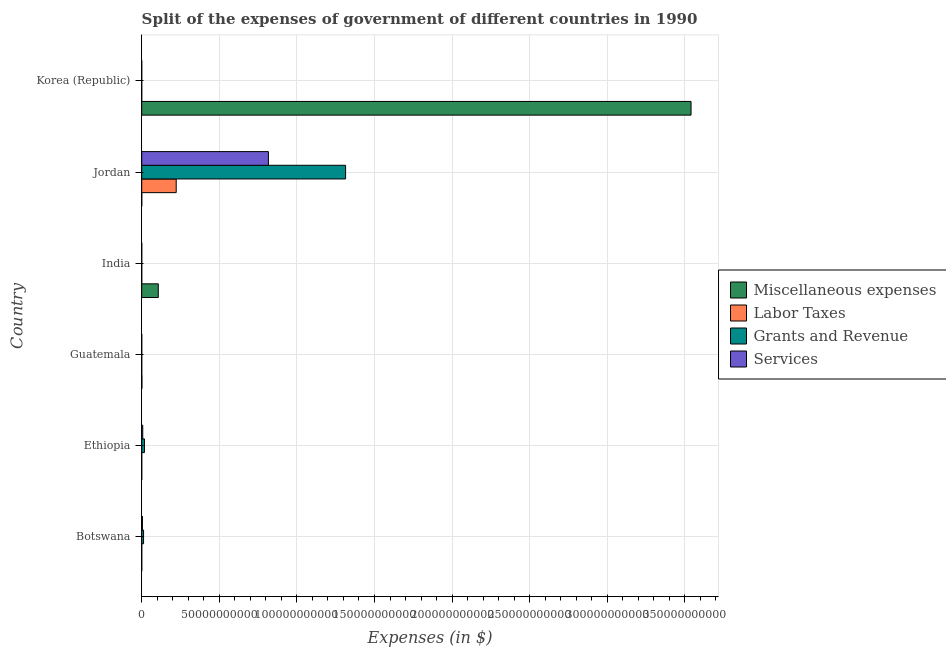How many groups of bars are there?
Give a very brief answer. 6. Are the number of bars per tick equal to the number of legend labels?
Provide a succinct answer. Yes. Are the number of bars on each tick of the Y-axis equal?
Offer a terse response. Yes. How many bars are there on the 1st tick from the top?
Your response must be concise. 4. How many bars are there on the 3rd tick from the bottom?
Offer a terse response. 4. What is the label of the 6th group of bars from the top?
Provide a succinct answer. Botswana. In how many cases, is the number of bars for a given country not equal to the number of legend labels?
Offer a terse response. 0. What is the amount spent on miscellaneous expenses in Jordan?
Keep it short and to the point. 1.91e+07. Across all countries, what is the maximum amount spent on labor taxes?
Provide a short and direct response. 2.22e+1. Across all countries, what is the minimum amount spent on miscellaneous expenses?
Provide a succinct answer. 9.70e+06. In which country was the amount spent on grants and revenue maximum?
Give a very brief answer. Jordan. In which country was the amount spent on services minimum?
Provide a short and direct response. Korea (Republic). What is the total amount spent on grants and revenue in the graph?
Provide a short and direct response. 1.34e+11. What is the difference between the amount spent on grants and revenue in Botswana and that in Jordan?
Your response must be concise. -1.30e+11. What is the difference between the amount spent on miscellaneous expenses in Botswana and the amount spent on services in India?
Your answer should be very brief. 1.35e+07. What is the average amount spent on labor taxes per country?
Your answer should be compact. 3.70e+09. What is the difference between the amount spent on miscellaneous expenses and amount spent on labor taxes in India?
Keep it short and to the point. 1.07e+1. In how many countries, is the amount spent on labor taxes greater than 350000000000 $?
Provide a short and direct response. 0. What is the ratio of the amount spent on services in Botswana to that in Korea (Republic)?
Your response must be concise. 2.21e+08. Is the amount spent on miscellaneous expenses in Guatemala less than that in India?
Provide a succinct answer. Yes. Is the difference between the amount spent on services in Botswana and Jordan greater than the difference between the amount spent on labor taxes in Botswana and Jordan?
Ensure brevity in your answer.  No. What is the difference between the highest and the second highest amount spent on miscellaneous expenses?
Ensure brevity in your answer.  3.43e+11. What is the difference between the highest and the lowest amount spent on grants and revenue?
Give a very brief answer. 1.31e+11. In how many countries, is the amount spent on grants and revenue greater than the average amount spent on grants and revenue taken over all countries?
Give a very brief answer. 1. Is the sum of the amount spent on labor taxes in Botswana and India greater than the maximum amount spent on services across all countries?
Your answer should be compact. No. What does the 1st bar from the top in Jordan represents?
Make the answer very short. Services. What does the 2nd bar from the bottom in Botswana represents?
Offer a very short reply. Labor Taxes. Is it the case that in every country, the sum of the amount spent on miscellaneous expenses and amount spent on labor taxes is greater than the amount spent on grants and revenue?
Your response must be concise. No. How many countries are there in the graph?
Ensure brevity in your answer.  6. What is the difference between two consecutive major ticks on the X-axis?
Give a very brief answer. 5.00e+1. Are the values on the major ticks of X-axis written in scientific E-notation?
Provide a short and direct response. No. How many legend labels are there?
Make the answer very short. 4. How are the legend labels stacked?
Your response must be concise. Vertical. What is the title of the graph?
Ensure brevity in your answer.  Split of the expenses of government of different countries in 1990. What is the label or title of the X-axis?
Keep it short and to the point. Expenses (in $). What is the label or title of the Y-axis?
Ensure brevity in your answer.  Country. What is the Expenses (in $) of Miscellaneous expenses in Botswana?
Ensure brevity in your answer.  2.16e+07. What is the Expenses (in $) in Labor Taxes in Botswana?
Give a very brief answer. 5.30e+06. What is the Expenses (in $) in Grants and Revenue in Botswana?
Ensure brevity in your answer.  1.18e+09. What is the Expenses (in $) in Services in Botswana?
Make the answer very short. 4.65e+08. What is the Expenses (in $) in Miscellaneous expenses in Ethiopia?
Give a very brief answer. 9.70e+06. What is the Expenses (in $) in Labor Taxes in Ethiopia?
Ensure brevity in your answer.  2.60e+06. What is the Expenses (in $) of Grants and Revenue in Ethiopia?
Make the answer very short. 1.76e+09. What is the Expenses (in $) in Services in Ethiopia?
Your answer should be compact. 6.62e+08. What is the Expenses (in $) of Miscellaneous expenses in Guatemala?
Your answer should be compact. 1.09e+08. What is the Expenses (in $) of Labor Taxes in Guatemala?
Provide a succinct answer. 1.56e+05. What is the Expenses (in $) in Grants and Revenue in Guatemala?
Your answer should be compact. 4.38e+05. What is the Expenses (in $) of Services in Guatemala?
Your response must be concise. 2.53e+05. What is the Expenses (in $) of Miscellaneous expenses in India?
Offer a terse response. 1.07e+1. What is the Expenses (in $) in Labor Taxes in India?
Provide a succinct answer. 2.01e+05. What is the Expenses (in $) in Grants and Revenue in India?
Ensure brevity in your answer.  6.21e+06. What is the Expenses (in $) of Services in India?
Keep it short and to the point. 8.09e+06. What is the Expenses (in $) of Miscellaneous expenses in Jordan?
Offer a terse response. 1.91e+07. What is the Expenses (in $) of Labor Taxes in Jordan?
Your response must be concise. 2.22e+1. What is the Expenses (in $) of Grants and Revenue in Jordan?
Offer a very short reply. 1.31e+11. What is the Expenses (in $) in Services in Jordan?
Your answer should be compact. 8.16e+1. What is the Expenses (in $) of Miscellaneous expenses in Korea (Republic)?
Give a very brief answer. 3.54e+11. What is the Expenses (in $) of Labor Taxes in Korea (Republic)?
Give a very brief answer. 0.03. What is the Expenses (in $) in Grants and Revenue in Korea (Republic)?
Offer a very short reply. 0.63. What is the Expenses (in $) in Services in Korea (Republic)?
Make the answer very short. 2.1. Across all countries, what is the maximum Expenses (in $) of Miscellaneous expenses?
Your response must be concise. 3.54e+11. Across all countries, what is the maximum Expenses (in $) in Labor Taxes?
Your answer should be compact. 2.22e+1. Across all countries, what is the maximum Expenses (in $) of Grants and Revenue?
Offer a terse response. 1.31e+11. Across all countries, what is the maximum Expenses (in $) of Services?
Your answer should be compact. 8.16e+1. Across all countries, what is the minimum Expenses (in $) of Miscellaneous expenses?
Your answer should be compact. 9.70e+06. Across all countries, what is the minimum Expenses (in $) in Labor Taxes?
Your response must be concise. 0.03. Across all countries, what is the minimum Expenses (in $) in Grants and Revenue?
Provide a succinct answer. 0.63. Across all countries, what is the minimum Expenses (in $) in Services?
Make the answer very short. 2.1. What is the total Expenses (in $) in Miscellaneous expenses in the graph?
Give a very brief answer. 3.65e+11. What is the total Expenses (in $) in Labor Taxes in the graph?
Offer a terse response. 2.22e+1. What is the total Expenses (in $) in Grants and Revenue in the graph?
Provide a short and direct response. 1.34e+11. What is the total Expenses (in $) in Services in the graph?
Offer a very short reply. 8.28e+1. What is the difference between the Expenses (in $) in Miscellaneous expenses in Botswana and that in Ethiopia?
Keep it short and to the point. 1.19e+07. What is the difference between the Expenses (in $) in Labor Taxes in Botswana and that in Ethiopia?
Make the answer very short. 2.70e+06. What is the difference between the Expenses (in $) of Grants and Revenue in Botswana and that in Ethiopia?
Keep it short and to the point. -5.76e+08. What is the difference between the Expenses (in $) in Services in Botswana and that in Ethiopia?
Offer a very short reply. -1.96e+08. What is the difference between the Expenses (in $) of Miscellaneous expenses in Botswana and that in Guatemala?
Provide a short and direct response. -8.79e+07. What is the difference between the Expenses (in $) of Labor Taxes in Botswana and that in Guatemala?
Keep it short and to the point. 5.14e+06. What is the difference between the Expenses (in $) of Grants and Revenue in Botswana and that in Guatemala?
Offer a terse response. 1.18e+09. What is the difference between the Expenses (in $) of Services in Botswana and that in Guatemala?
Make the answer very short. 4.65e+08. What is the difference between the Expenses (in $) in Miscellaneous expenses in Botswana and that in India?
Keep it short and to the point. -1.07e+1. What is the difference between the Expenses (in $) in Labor Taxes in Botswana and that in India?
Your response must be concise. 5.10e+06. What is the difference between the Expenses (in $) of Grants and Revenue in Botswana and that in India?
Make the answer very short. 1.18e+09. What is the difference between the Expenses (in $) in Services in Botswana and that in India?
Provide a short and direct response. 4.57e+08. What is the difference between the Expenses (in $) of Miscellaneous expenses in Botswana and that in Jordan?
Your response must be concise. 2.43e+06. What is the difference between the Expenses (in $) in Labor Taxes in Botswana and that in Jordan?
Ensure brevity in your answer.  -2.22e+1. What is the difference between the Expenses (in $) in Grants and Revenue in Botswana and that in Jordan?
Ensure brevity in your answer.  -1.30e+11. What is the difference between the Expenses (in $) of Services in Botswana and that in Jordan?
Your response must be concise. -8.12e+1. What is the difference between the Expenses (in $) in Miscellaneous expenses in Botswana and that in Korea (Republic)?
Keep it short and to the point. -3.54e+11. What is the difference between the Expenses (in $) of Labor Taxes in Botswana and that in Korea (Republic)?
Provide a succinct answer. 5.30e+06. What is the difference between the Expenses (in $) in Grants and Revenue in Botswana and that in Korea (Republic)?
Give a very brief answer. 1.18e+09. What is the difference between the Expenses (in $) of Services in Botswana and that in Korea (Republic)?
Keep it short and to the point. 4.65e+08. What is the difference between the Expenses (in $) in Miscellaneous expenses in Ethiopia and that in Guatemala?
Your answer should be compact. -9.97e+07. What is the difference between the Expenses (in $) in Labor Taxes in Ethiopia and that in Guatemala?
Your answer should be compact. 2.44e+06. What is the difference between the Expenses (in $) of Grants and Revenue in Ethiopia and that in Guatemala?
Your response must be concise. 1.76e+09. What is the difference between the Expenses (in $) of Services in Ethiopia and that in Guatemala?
Your answer should be compact. 6.61e+08. What is the difference between the Expenses (in $) in Miscellaneous expenses in Ethiopia and that in India?
Your response must be concise. -1.07e+1. What is the difference between the Expenses (in $) in Labor Taxes in Ethiopia and that in India?
Your response must be concise. 2.40e+06. What is the difference between the Expenses (in $) of Grants and Revenue in Ethiopia and that in India?
Offer a very short reply. 1.75e+09. What is the difference between the Expenses (in $) in Services in Ethiopia and that in India?
Your answer should be very brief. 6.53e+08. What is the difference between the Expenses (in $) of Miscellaneous expenses in Ethiopia and that in Jordan?
Your answer should be very brief. -9.43e+06. What is the difference between the Expenses (in $) of Labor Taxes in Ethiopia and that in Jordan?
Your answer should be compact. -2.22e+1. What is the difference between the Expenses (in $) of Grants and Revenue in Ethiopia and that in Jordan?
Your answer should be compact. -1.30e+11. What is the difference between the Expenses (in $) in Services in Ethiopia and that in Jordan?
Your answer should be compact. -8.10e+1. What is the difference between the Expenses (in $) of Miscellaneous expenses in Ethiopia and that in Korea (Republic)?
Provide a succinct answer. -3.54e+11. What is the difference between the Expenses (in $) of Labor Taxes in Ethiopia and that in Korea (Republic)?
Your answer should be compact. 2.60e+06. What is the difference between the Expenses (in $) of Grants and Revenue in Ethiopia and that in Korea (Republic)?
Give a very brief answer. 1.76e+09. What is the difference between the Expenses (in $) of Services in Ethiopia and that in Korea (Republic)?
Offer a very short reply. 6.62e+08. What is the difference between the Expenses (in $) in Miscellaneous expenses in Guatemala and that in India?
Offer a very short reply. -1.06e+1. What is the difference between the Expenses (in $) of Labor Taxes in Guatemala and that in India?
Give a very brief answer. -4.51e+04. What is the difference between the Expenses (in $) in Grants and Revenue in Guatemala and that in India?
Give a very brief answer. -5.77e+06. What is the difference between the Expenses (in $) of Services in Guatemala and that in India?
Keep it short and to the point. -7.84e+06. What is the difference between the Expenses (in $) of Miscellaneous expenses in Guatemala and that in Jordan?
Your answer should be very brief. 9.03e+07. What is the difference between the Expenses (in $) of Labor Taxes in Guatemala and that in Jordan?
Give a very brief answer. -2.22e+1. What is the difference between the Expenses (in $) in Grants and Revenue in Guatemala and that in Jordan?
Offer a very short reply. -1.31e+11. What is the difference between the Expenses (in $) of Services in Guatemala and that in Jordan?
Give a very brief answer. -8.16e+1. What is the difference between the Expenses (in $) in Miscellaneous expenses in Guatemala and that in Korea (Republic)?
Provide a short and direct response. -3.54e+11. What is the difference between the Expenses (in $) in Labor Taxes in Guatemala and that in Korea (Republic)?
Make the answer very short. 1.56e+05. What is the difference between the Expenses (in $) of Grants and Revenue in Guatemala and that in Korea (Republic)?
Provide a succinct answer. 4.38e+05. What is the difference between the Expenses (in $) of Services in Guatemala and that in Korea (Republic)?
Your answer should be very brief. 2.53e+05. What is the difference between the Expenses (in $) in Miscellaneous expenses in India and that in Jordan?
Offer a terse response. 1.07e+1. What is the difference between the Expenses (in $) in Labor Taxes in India and that in Jordan?
Provide a succinct answer. -2.22e+1. What is the difference between the Expenses (in $) of Grants and Revenue in India and that in Jordan?
Your response must be concise. -1.31e+11. What is the difference between the Expenses (in $) in Services in India and that in Jordan?
Ensure brevity in your answer.  -8.16e+1. What is the difference between the Expenses (in $) of Miscellaneous expenses in India and that in Korea (Republic)?
Keep it short and to the point. -3.43e+11. What is the difference between the Expenses (in $) in Labor Taxes in India and that in Korea (Republic)?
Give a very brief answer. 2.01e+05. What is the difference between the Expenses (in $) in Grants and Revenue in India and that in Korea (Republic)?
Your response must be concise. 6.21e+06. What is the difference between the Expenses (in $) in Services in India and that in Korea (Republic)?
Make the answer very short. 8.09e+06. What is the difference between the Expenses (in $) of Miscellaneous expenses in Jordan and that in Korea (Republic)?
Provide a succinct answer. -3.54e+11. What is the difference between the Expenses (in $) of Labor Taxes in Jordan and that in Korea (Republic)?
Your response must be concise. 2.22e+1. What is the difference between the Expenses (in $) in Grants and Revenue in Jordan and that in Korea (Republic)?
Provide a succinct answer. 1.31e+11. What is the difference between the Expenses (in $) in Services in Jordan and that in Korea (Republic)?
Your answer should be very brief. 8.16e+1. What is the difference between the Expenses (in $) of Miscellaneous expenses in Botswana and the Expenses (in $) of Labor Taxes in Ethiopia?
Provide a succinct answer. 1.90e+07. What is the difference between the Expenses (in $) in Miscellaneous expenses in Botswana and the Expenses (in $) in Grants and Revenue in Ethiopia?
Make the answer very short. -1.74e+09. What is the difference between the Expenses (in $) of Miscellaneous expenses in Botswana and the Expenses (in $) of Services in Ethiopia?
Ensure brevity in your answer.  -6.40e+08. What is the difference between the Expenses (in $) of Labor Taxes in Botswana and the Expenses (in $) of Grants and Revenue in Ethiopia?
Give a very brief answer. -1.75e+09. What is the difference between the Expenses (in $) in Labor Taxes in Botswana and the Expenses (in $) in Services in Ethiopia?
Offer a very short reply. -6.56e+08. What is the difference between the Expenses (in $) of Grants and Revenue in Botswana and the Expenses (in $) of Services in Ethiopia?
Your response must be concise. 5.23e+08. What is the difference between the Expenses (in $) of Miscellaneous expenses in Botswana and the Expenses (in $) of Labor Taxes in Guatemala?
Ensure brevity in your answer.  2.14e+07. What is the difference between the Expenses (in $) of Miscellaneous expenses in Botswana and the Expenses (in $) of Grants and Revenue in Guatemala?
Your response must be concise. 2.11e+07. What is the difference between the Expenses (in $) of Miscellaneous expenses in Botswana and the Expenses (in $) of Services in Guatemala?
Your answer should be very brief. 2.13e+07. What is the difference between the Expenses (in $) in Labor Taxes in Botswana and the Expenses (in $) in Grants and Revenue in Guatemala?
Give a very brief answer. 4.86e+06. What is the difference between the Expenses (in $) of Labor Taxes in Botswana and the Expenses (in $) of Services in Guatemala?
Your answer should be very brief. 5.05e+06. What is the difference between the Expenses (in $) of Grants and Revenue in Botswana and the Expenses (in $) of Services in Guatemala?
Your response must be concise. 1.18e+09. What is the difference between the Expenses (in $) in Miscellaneous expenses in Botswana and the Expenses (in $) in Labor Taxes in India?
Ensure brevity in your answer.  2.14e+07. What is the difference between the Expenses (in $) in Miscellaneous expenses in Botswana and the Expenses (in $) in Grants and Revenue in India?
Ensure brevity in your answer.  1.54e+07. What is the difference between the Expenses (in $) in Miscellaneous expenses in Botswana and the Expenses (in $) in Services in India?
Your response must be concise. 1.35e+07. What is the difference between the Expenses (in $) in Labor Taxes in Botswana and the Expenses (in $) in Grants and Revenue in India?
Give a very brief answer. -9.07e+05. What is the difference between the Expenses (in $) in Labor Taxes in Botswana and the Expenses (in $) in Services in India?
Offer a terse response. -2.79e+06. What is the difference between the Expenses (in $) in Grants and Revenue in Botswana and the Expenses (in $) in Services in India?
Your answer should be compact. 1.18e+09. What is the difference between the Expenses (in $) in Miscellaneous expenses in Botswana and the Expenses (in $) in Labor Taxes in Jordan?
Make the answer very short. -2.22e+1. What is the difference between the Expenses (in $) in Miscellaneous expenses in Botswana and the Expenses (in $) in Grants and Revenue in Jordan?
Give a very brief answer. -1.31e+11. What is the difference between the Expenses (in $) in Miscellaneous expenses in Botswana and the Expenses (in $) in Services in Jordan?
Give a very brief answer. -8.16e+1. What is the difference between the Expenses (in $) in Labor Taxes in Botswana and the Expenses (in $) in Grants and Revenue in Jordan?
Offer a very short reply. -1.31e+11. What is the difference between the Expenses (in $) of Labor Taxes in Botswana and the Expenses (in $) of Services in Jordan?
Give a very brief answer. -8.16e+1. What is the difference between the Expenses (in $) of Grants and Revenue in Botswana and the Expenses (in $) of Services in Jordan?
Offer a very short reply. -8.05e+1. What is the difference between the Expenses (in $) of Miscellaneous expenses in Botswana and the Expenses (in $) of Labor Taxes in Korea (Republic)?
Give a very brief answer. 2.16e+07. What is the difference between the Expenses (in $) in Miscellaneous expenses in Botswana and the Expenses (in $) in Grants and Revenue in Korea (Republic)?
Give a very brief answer. 2.16e+07. What is the difference between the Expenses (in $) of Miscellaneous expenses in Botswana and the Expenses (in $) of Services in Korea (Republic)?
Your response must be concise. 2.16e+07. What is the difference between the Expenses (in $) in Labor Taxes in Botswana and the Expenses (in $) in Grants and Revenue in Korea (Republic)?
Your response must be concise. 5.30e+06. What is the difference between the Expenses (in $) of Labor Taxes in Botswana and the Expenses (in $) of Services in Korea (Republic)?
Offer a terse response. 5.30e+06. What is the difference between the Expenses (in $) of Grants and Revenue in Botswana and the Expenses (in $) of Services in Korea (Republic)?
Offer a terse response. 1.18e+09. What is the difference between the Expenses (in $) of Miscellaneous expenses in Ethiopia and the Expenses (in $) of Labor Taxes in Guatemala?
Offer a very short reply. 9.54e+06. What is the difference between the Expenses (in $) of Miscellaneous expenses in Ethiopia and the Expenses (in $) of Grants and Revenue in Guatemala?
Offer a very short reply. 9.26e+06. What is the difference between the Expenses (in $) in Miscellaneous expenses in Ethiopia and the Expenses (in $) in Services in Guatemala?
Provide a succinct answer. 9.45e+06. What is the difference between the Expenses (in $) in Labor Taxes in Ethiopia and the Expenses (in $) in Grants and Revenue in Guatemala?
Keep it short and to the point. 2.16e+06. What is the difference between the Expenses (in $) of Labor Taxes in Ethiopia and the Expenses (in $) of Services in Guatemala?
Your response must be concise. 2.35e+06. What is the difference between the Expenses (in $) of Grants and Revenue in Ethiopia and the Expenses (in $) of Services in Guatemala?
Provide a short and direct response. 1.76e+09. What is the difference between the Expenses (in $) of Miscellaneous expenses in Ethiopia and the Expenses (in $) of Labor Taxes in India?
Offer a very short reply. 9.50e+06. What is the difference between the Expenses (in $) in Miscellaneous expenses in Ethiopia and the Expenses (in $) in Grants and Revenue in India?
Keep it short and to the point. 3.49e+06. What is the difference between the Expenses (in $) of Miscellaneous expenses in Ethiopia and the Expenses (in $) of Services in India?
Provide a short and direct response. 1.61e+06. What is the difference between the Expenses (in $) of Labor Taxes in Ethiopia and the Expenses (in $) of Grants and Revenue in India?
Offer a very short reply. -3.61e+06. What is the difference between the Expenses (in $) in Labor Taxes in Ethiopia and the Expenses (in $) in Services in India?
Make the answer very short. -5.49e+06. What is the difference between the Expenses (in $) in Grants and Revenue in Ethiopia and the Expenses (in $) in Services in India?
Offer a terse response. 1.75e+09. What is the difference between the Expenses (in $) in Miscellaneous expenses in Ethiopia and the Expenses (in $) in Labor Taxes in Jordan?
Keep it short and to the point. -2.22e+1. What is the difference between the Expenses (in $) in Miscellaneous expenses in Ethiopia and the Expenses (in $) in Grants and Revenue in Jordan?
Your response must be concise. -1.31e+11. What is the difference between the Expenses (in $) in Miscellaneous expenses in Ethiopia and the Expenses (in $) in Services in Jordan?
Ensure brevity in your answer.  -8.16e+1. What is the difference between the Expenses (in $) in Labor Taxes in Ethiopia and the Expenses (in $) in Grants and Revenue in Jordan?
Offer a very short reply. -1.31e+11. What is the difference between the Expenses (in $) in Labor Taxes in Ethiopia and the Expenses (in $) in Services in Jordan?
Offer a very short reply. -8.16e+1. What is the difference between the Expenses (in $) of Grants and Revenue in Ethiopia and the Expenses (in $) of Services in Jordan?
Provide a short and direct response. -7.99e+1. What is the difference between the Expenses (in $) in Miscellaneous expenses in Ethiopia and the Expenses (in $) in Labor Taxes in Korea (Republic)?
Your answer should be compact. 9.70e+06. What is the difference between the Expenses (in $) in Miscellaneous expenses in Ethiopia and the Expenses (in $) in Grants and Revenue in Korea (Republic)?
Ensure brevity in your answer.  9.70e+06. What is the difference between the Expenses (in $) of Miscellaneous expenses in Ethiopia and the Expenses (in $) of Services in Korea (Republic)?
Keep it short and to the point. 9.70e+06. What is the difference between the Expenses (in $) in Labor Taxes in Ethiopia and the Expenses (in $) in Grants and Revenue in Korea (Republic)?
Ensure brevity in your answer.  2.60e+06. What is the difference between the Expenses (in $) in Labor Taxes in Ethiopia and the Expenses (in $) in Services in Korea (Republic)?
Ensure brevity in your answer.  2.60e+06. What is the difference between the Expenses (in $) of Grants and Revenue in Ethiopia and the Expenses (in $) of Services in Korea (Republic)?
Make the answer very short. 1.76e+09. What is the difference between the Expenses (in $) of Miscellaneous expenses in Guatemala and the Expenses (in $) of Labor Taxes in India?
Provide a succinct answer. 1.09e+08. What is the difference between the Expenses (in $) in Miscellaneous expenses in Guatemala and the Expenses (in $) in Grants and Revenue in India?
Provide a succinct answer. 1.03e+08. What is the difference between the Expenses (in $) in Miscellaneous expenses in Guatemala and the Expenses (in $) in Services in India?
Offer a terse response. 1.01e+08. What is the difference between the Expenses (in $) in Labor Taxes in Guatemala and the Expenses (in $) in Grants and Revenue in India?
Your answer should be compact. -6.05e+06. What is the difference between the Expenses (in $) of Labor Taxes in Guatemala and the Expenses (in $) of Services in India?
Your answer should be very brief. -7.93e+06. What is the difference between the Expenses (in $) in Grants and Revenue in Guatemala and the Expenses (in $) in Services in India?
Give a very brief answer. -7.65e+06. What is the difference between the Expenses (in $) of Miscellaneous expenses in Guatemala and the Expenses (in $) of Labor Taxes in Jordan?
Offer a terse response. -2.21e+1. What is the difference between the Expenses (in $) in Miscellaneous expenses in Guatemala and the Expenses (in $) in Grants and Revenue in Jordan?
Make the answer very short. -1.31e+11. What is the difference between the Expenses (in $) in Miscellaneous expenses in Guatemala and the Expenses (in $) in Services in Jordan?
Your response must be concise. -8.15e+1. What is the difference between the Expenses (in $) in Labor Taxes in Guatemala and the Expenses (in $) in Grants and Revenue in Jordan?
Provide a succinct answer. -1.31e+11. What is the difference between the Expenses (in $) of Labor Taxes in Guatemala and the Expenses (in $) of Services in Jordan?
Offer a terse response. -8.16e+1. What is the difference between the Expenses (in $) in Grants and Revenue in Guatemala and the Expenses (in $) in Services in Jordan?
Provide a short and direct response. -8.16e+1. What is the difference between the Expenses (in $) of Miscellaneous expenses in Guatemala and the Expenses (in $) of Labor Taxes in Korea (Republic)?
Your answer should be very brief. 1.09e+08. What is the difference between the Expenses (in $) of Miscellaneous expenses in Guatemala and the Expenses (in $) of Grants and Revenue in Korea (Republic)?
Make the answer very short. 1.09e+08. What is the difference between the Expenses (in $) of Miscellaneous expenses in Guatemala and the Expenses (in $) of Services in Korea (Republic)?
Your answer should be very brief. 1.09e+08. What is the difference between the Expenses (in $) in Labor Taxes in Guatemala and the Expenses (in $) in Grants and Revenue in Korea (Republic)?
Offer a terse response. 1.56e+05. What is the difference between the Expenses (in $) in Labor Taxes in Guatemala and the Expenses (in $) in Services in Korea (Republic)?
Provide a short and direct response. 1.56e+05. What is the difference between the Expenses (in $) in Grants and Revenue in Guatemala and the Expenses (in $) in Services in Korea (Republic)?
Your answer should be very brief. 4.38e+05. What is the difference between the Expenses (in $) in Miscellaneous expenses in India and the Expenses (in $) in Labor Taxes in Jordan?
Make the answer very short. -1.15e+1. What is the difference between the Expenses (in $) in Miscellaneous expenses in India and the Expenses (in $) in Grants and Revenue in Jordan?
Your answer should be very brief. -1.21e+11. What is the difference between the Expenses (in $) of Miscellaneous expenses in India and the Expenses (in $) of Services in Jordan?
Keep it short and to the point. -7.10e+1. What is the difference between the Expenses (in $) of Labor Taxes in India and the Expenses (in $) of Grants and Revenue in Jordan?
Offer a terse response. -1.31e+11. What is the difference between the Expenses (in $) of Labor Taxes in India and the Expenses (in $) of Services in Jordan?
Ensure brevity in your answer.  -8.16e+1. What is the difference between the Expenses (in $) in Grants and Revenue in India and the Expenses (in $) in Services in Jordan?
Keep it short and to the point. -8.16e+1. What is the difference between the Expenses (in $) of Miscellaneous expenses in India and the Expenses (in $) of Labor Taxes in Korea (Republic)?
Your answer should be compact. 1.07e+1. What is the difference between the Expenses (in $) of Miscellaneous expenses in India and the Expenses (in $) of Grants and Revenue in Korea (Republic)?
Provide a short and direct response. 1.07e+1. What is the difference between the Expenses (in $) of Miscellaneous expenses in India and the Expenses (in $) of Services in Korea (Republic)?
Keep it short and to the point. 1.07e+1. What is the difference between the Expenses (in $) of Labor Taxes in India and the Expenses (in $) of Grants and Revenue in Korea (Republic)?
Your response must be concise. 2.01e+05. What is the difference between the Expenses (in $) of Labor Taxes in India and the Expenses (in $) of Services in Korea (Republic)?
Offer a terse response. 2.01e+05. What is the difference between the Expenses (in $) of Grants and Revenue in India and the Expenses (in $) of Services in Korea (Republic)?
Your answer should be compact. 6.21e+06. What is the difference between the Expenses (in $) in Miscellaneous expenses in Jordan and the Expenses (in $) in Labor Taxes in Korea (Republic)?
Provide a short and direct response. 1.91e+07. What is the difference between the Expenses (in $) of Miscellaneous expenses in Jordan and the Expenses (in $) of Grants and Revenue in Korea (Republic)?
Provide a succinct answer. 1.91e+07. What is the difference between the Expenses (in $) in Miscellaneous expenses in Jordan and the Expenses (in $) in Services in Korea (Republic)?
Provide a succinct answer. 1.91e+07. What is the difference between the Expenses (in $) of Labor Taxes in Jordan and the Expenses (in $) of Grants and Revenue in Korea (Republic)?
Ensure brevity in your answer.  2.22e+1. What is the difference between the Expenses (in $) in Labor Taxes in Jordan and the Expenses (in $) in Services in Korea (Republic)?
Your answer should be very brief. 2.22e+1. What is the difference between the Expenses (in $) in Grants and Revenue in Jordan and the Expenses (in $) in Services in Korea (Republic)?
Your answer should be compact. 1.31e+11. What is the average Expenses (in $) of Miscellaneous expenses per country?
Give a very brief answer. 6.08e+1. What is the average Expenses (in $) of Labor Taxes per country?
Your answer should be very brief. 3.70e+09. What is the average Expenses (in $) in Grants and Revenue per country?
Keep it short and to the point. 2.24e+1. What is the average Expenses (in $) of Services per country?
Offer a terse response. 1.38e+1. What is the difference between the Expenses (in $) in Miscellaneous expenses and Expenses (in $) in Labor Taxes in Botswana?
Offer a very short reply. 1.63e+07. What is the difference between the Expenses (in $) of Miscellaneous expenses and Expenses (in $) of Grants and Revenue in Botswana?
Ensure brevity in your answer.  -1.16e+09. What is the difference between the Expenses (in $) of Miscellaneous expenses and Expenses (in $) of Services in Botswana?
Offer a terse response. -4.44e+08. What is the difference between the Expenses (in $) in Labor Taxes and Expenses (in $) in Grants and Revenue in Botswana?
Provide a succinct answer. -1.18e+09. What is the difference between the Expenses (in $) of Labor Taxes and Expenses (in $) of Services in Botswana?
Your response must be concise. -4.60e+08. What is the difference between the Expenses (in $) of Grants and Revenue and Expenses (in $) of Services in Botswana?
Your answer should be compact. 7.19e+08. What is the difference between the Expenses (in $) of Miscellaneous expenses and Expenses (in $) of Labor Taxes in Ethiopia?
Ensure brevity in your answer.  7.10e+06. What is the difference between the Expenses (in $) in Miscellaneous expenses and Expenses (in $) in Grants and Revenue in Ethiopia?
Offer a terse response. -1.75e+09. What is the difference between the Expenses (in $) of Miscellaneous expenses and Expenses (in $) of Services in Ethiopia?
Make the answer very short. -6.52e+08. What is the difference between the Expenses (in $) of Labor Taxes and Expenses (in $) of Grants and Revenue in Ethiopia?
Offer a very short reply. -1.76e+09. What is the difference between the Expenses (in $) in Labor Taxes and Expenses (in $) in Services in Ethiopia?
Your answer should be compact. -6.59e+08. What is the difference between the Expenses (in $) in Grants and Revenue and Expenses (in $) in Services in Ethiopia?
Offer a very short reply. 1.10e+09. What is the difference between the Expenses (in $) in Miscellaneous expenses and Expenses (in $) in Labor Taxes in Guatemala?
Offer a terse response. 1.09e+08. What is the difference between the Expenses (in $) in Miscellaneous expenses and Expenses (in $) in Grants and Revenue in Guatemala?
Ensure brevity in your answer.  1.09e+08. What is the difference between the Expenses (in $) of Miscellaneous expenses and Expenses (in $) of Services in Guatemala?
Provide a succinct answer. 1.09e+08. What is the difference between the Expenses (in $) of Labor Taxes and Expenses (in $) of Grants and Revenue in Guatemala?
Your response must be concise. -2.82e+05. What is the difference between the Expenses (in $) in Labor Taxes and Expenses (in $) in Services in Guatemala?
Your answer should be compact. -9.71e+04. What is the difference between the Expenses (in $) in Grants and Revenue and Expenses (in $) in Services in Guatemala?
Your response must be concise. 1.85e+05. What is the difference between the Expenses (in $) of Miscellaneous expenses and Expenses (in $) of Labor Taxes in India?
Your answer should be very brief. 1.07e+1. What is the difference between the Expenses (in $) of Miscellaneous expenses and Expenses (in $) of Grants and Revenue in India?
Make the answer very short. 1.07e+1. What is the difference between the Expenses (in $) in Miscellaneous expenses and Expenses (in $) in Services in India?
Offer a terse response. 1.07e+1. What is the difference between the Expenses (in $) of Labor Taxes and Expenses (in $) of Grants and Revenue in India?
Your response must be concise. -6.01e+06. What is the difference between the Expenses (in $) of Labor Taxes and Expenses (in $) of Services in India?
Make the answer very short. -7.89e+06. What is the difference between the Expenses (in $) in Grants and Revenue and Expenses (in $) in Services in India?
Offer a very short reply. -1.88e+06. What is the difference between the Expenses (in $) of Miscellaneous expenses and Expenses (in $) of Labor Taxes in Jordan?
Offer a terse response. -2.22e+1. What is the difference between the Expenses (in $) in Miscellaneous expenses and Expenses (in $) in Grants and Revenue in Jordan?
Give a very brief answer. -1.31e+11. What is the difference between the Expenses (in $) of Miscellaneous expenses and Expenses (in $) of Services in Jordan?
Your answer should be compact. -8.16e+1. What is the difference between the Expenses (in $) of Labor Taxes and Expenses (in $) of Grants and Revenue in Jordan?
Provide a succinct answer. -1.09e+11. What is the difference between the Expenses (in $) in Labor Taxes and Expenses (in $) in Services in Jordan?
Make the answer very short. -5.94e+1. What is the difference between the Expenses (in $) of Grants and Revenue and Expenses (in $) of Services in Jordan?
Make the answer very short. 4.97e+1. What is the difference between the Expenses (in $) in Miscellaneous expenses and Expenses (in $) in Labor Taxes in Korea (Republic)?
Your answer should be compact. 3.54e+11. What is the difference between the Expenses (in $) in Miscellaneous expenses and Expenses (in $) in Grants and Revenue in Korea (Republic)?
Your answer should be compact. 3.54e+11. What is the difference between the Expenses (in $) in Miscellaneous expenses and Expenses (in $) in Services in Korea (Republic)?
Offer a terse response. 3.54e+11. What is the difference between the Expenses (in $) in Labor Taxes and Expenses (in $) in Grants and Revenue in Korea (Republic)?
Provide a short and direct response. -0.6. What is the difference between the Expenses (in $) in Labor Taxes and Expenses (in $) in Services in Korea (Republic)?
Give a very brief answer. -2.07. What is the difference between the Expenses (in $) in Grants and Revenue and Expenses (in $) in Services in Korea (Republic)?
Give a very brief answer. -1.47. What is the ratio of the Expenses (in $) in Miscellaneous expenses in Botswana to that in Ethiopia?
Your answer should be very brief. 2.22. What is the ratio of the Expenses (in $) in Labor Taxes in Botswana to that in Ethiopia?
Offer a terse response. 2.04. What is the ratio of the Expenses (in $) of Grants and Revenue in Botswana to that in Ethiopia?
Ensure brevity in your answer.  0.67. What is the ratio of the Expenses (in $) of Services in Botswana to that in Ethiopia?
Offer a very short reply. 0.7. What is the ratio of the Expenses (in $) in Miscellaneous expenses in Botswana to that in Guatemala?
Your answer should be very brief. 0.2. What is the ratio of the Expenses (in $) of Labor Taxes in Botswana to that in Guatemala?
Make the answer very short. 34. What is the ratio of the Expenses (in $) in Grants and Revenue in Botswana to that in Guatemala?
Your answer should be compact. 2704.55. What is the ratio of the Expenses (in $) of Services in Botswana to that in Guatemala?
Give a very brief answer. 1839. What is the ratio of the Expenses (in $) of Miscellaneous expenses in Botswana to that in India?
Keep it short and to the point. 0. What is the ratio of the Expenses (in $) of Labor Taxes in Botswana to that in India?
Your answer should be compact. 26.37. What is the ratio of the Expenses (in $) in Grants and Revenue in Botswana to that in India?
Your response must be concise. 190.77. What is the ratio of the Expenses (in $) in Services in Botswana to that in India?
Make the answer very short. 57.52. What is the ratio of the Expenses (in $) of Miscellaneous expenses in Botswana to that in Jordan?
Ensure brevity in your answer.  1.13. What is the ratio of the Expenses (in $) of Labor Taxes in Botswana to that in Jordan?
Your answer should be very brief. 0. What is the ratio of the Expenses (in $) in Grants and Revenue in Botswana to that in Jordan?
Offer a very short reply. 0.01. What is the ratio of the Expenses (in $) of Services in Botswana to that in Jordan?
Give a very brief answer. 0.01. What is the ratio of the Expenses (in $) of Miscellaneous expenses in Botswana to that in Korea (Republic)?
Your response must be concise. 0. What is the ratio of the Expenses (in $) of Labor Taxes in Botswana to that in Korea (Republic)?
Provide a short and direct response. 1.72e+08. What is the ratio of the Expenses (in $) of Grants and Revenue in Botswana to that in Korea (Republic)?
Make the answer very short. 1.87e+09. What is the ratio of the Expenses (in $) in Services in Botswana to that in Korea (Republic)?
Ensure brevity in your answer.  2.21e+08. What is the ratio of the Expenses (in $) in Miscellaneous expenses in Ethiopia to that in Guatemala?
Provide a succinct answer. 0.09. What is the ratio of the Expenses (in $) of Labor Taxes in Ethiopia to that in Guatemala?
Make the answer very short. 16.68. What is the ratio of the Expenses (in $) in Grants and Revenue in Ethiopia to that in Guatemala?
Provide a succinct answer. 4019.98. What is the ratio of the Expenses (in $) in Services in Ethiopia to that in Guatemala?
Provide a succinct answer. 2614.71. What is the ratio of the Expenses (in $) in Miscellaneous expenses in Ethiopia to that in India?
Ensure brevity in your answer.  0. What is the ratio of the Expenses (in $) of Labor Taxes in Ethiopia to that in India?
Your answer should be compact. 12.94. What is the ratio of the Expenses (in $) of Grants and Revenue in Ethiopia to that in India?
Offer a very short reply. 283.55. What is the ratio of the Expenses (in $) in Services in Ethiopia to that in India?
Make the answer very short. 81.78. What is the ratio of the Expenses (in $) of Miscellaneous expenses in Ethiopia to that in Jordan?
Ensure brevity in your answer.  0.51. What is the ratio of the Expenses (in $) in Grants and Revenue in Ethiopia to that in Jordan?
Provide a short and direct response. 0.01. What is the ratio of the Expenses (in $) in Services in Ethiopia to that in Jordan?
Your answer should be very brief. 0.01. What is the ratio of the Expenses (in $) in Labor Taxes in Ethiopia to that in Korea (Republic)?
Offer a very short reply. 8.42e+07. What is the ratio of the Expenses (in $) of Grants and Revenue in Ethiopia to that in Korea (Republic)?
Your response must be concise. 2.78e+09. What is the ratio of the Expenses (in $) in Services in Ethiopia to that in Korea (Republic)?
Make the answer very short. 3.15e+08. What is the ratio of the Expenses (in $) of Miscellaneous expenses in Guatemala to that in India?
Ensure brevity in your answer.  0.01. What is the ratio of the Expenses (in $) in Labor Taxes in Guatemala to that in India?
Your answer should be very brief. 0.78. What is the ratio of the Expenses (in $) in Grants and Revenue in Guatemala to that in India?
Ensure brevity in your answer.  0.07. What is the ratio of the Expenses (in $) of Services in Guatemala to that in India?
Offer a very short reply. 0.03. What is the ratio of the Expenses (in $) of Miscellaneous expenses in Guatemala to that in Jordan?
Your answer should be compact. 5.72. What is the ratio of the Expenses (in $) in Miscellaneous expenses in Guatemala to that in Korea (Republic)?
Offer a terse response. 0. What is the ratio of the Expenses (in $) of Labor Taxes in Guatemala to that in Korea (Republic)?
Offer a terse response. 5.05e+06. What is the ratio of the Expenses (in $) in Grants and Revenue in Guatemala to that in Korea (Republic)?
Make the answer very short. 6.92e+05. What is the ratio of the Expenses (in $) in Services in Guatemala to that in Korea (Republic)?
Provide a short and direct response. 1.20e+05. What is the ratio of the Expenses (in $) in Miscellaneous expenses in India to that in Jordan?
Your response must be concise. 558.29. What is the ratio of the Expenses (in $) in Labor Taxes in India to that in Jordan?
Give a very brief answer. 0. What is the ratio of the Expenses (in $) in Grants and Revenue in India to that in Jordan?
Give a very brief answer. 0. What is the ratio of the Expenses (in $) in Miscellaneous expenses in India to that in Korea (Republic)?
Make the answer very short. 0.03. What is the ratio of the Expenses (in $) in Labor Taxes in India to that in Korea (Republic)?
Give a very brief answer. 6.51e+06. What is the ratio of the Expenses (in $) in Grants and Revenue in India to that in Korea (Republic)?
Provide a short and direct response. 9.81e+06. What is the ratio of the Expenses (in $) of Services in India to that in Korea (Republic)?
Your answer should be compact. 3.85e+06. What is the ratio of the Expenses (in $) of Miscellaneous expenses in Jordan to that in Korea (Republic)?
Provide a short and direct response. 0. What is the ratio of the Expenses (in $) of Labor Taxes in Jordan to that in Korea (Republic)?
Make the answer very short. 7.20e+11. What is the ratio of the Expenses (in $) of Grants and Revenue in Jordan to that in Korea (Republic)?
Make the answer very short. 2.08e+11. What is the ratio of the Expenses (in $) of Services in Jordan to that in Korea (Republic)?
Your answer should be very brief. 3.88e+1. What is the difference between the highest and the second highest Expenses (in $) of Miscellaneous expenses?
Ensure brevity in your answer.  3.43e+11. What is the difference between the highest and the second highest Expenses (in $) in Labor Taxes?
Your answer should be very brief. 2.22e+1. What is the difference between the highest and the second highest Expenses (in $) in Grants and Revenue?
Provide a short and direct response. 1.30e+11. What is the difference between the highest and the second highest Expenses (in $) in Services?
Offer a terse response. 8.10e+1. What is the difference between the highest and the lowest Expenses (in $) in Miscellaneous expenses?
Make the answer very short. 3.54e+11. What is the difference between the highest and the lowest Expenses (in $) of Labor Taxes?
Offer a very short reply. 2.22e+1. What is the difference between the highest and the lowest Expenses (in $) of Grants and Revenue?
Keep it short and to the point. 1.31e+11. What is the difference between the highest and the lowest Expenses (in $) of Services?
Your answer should be very brief. 8.16e+1. 